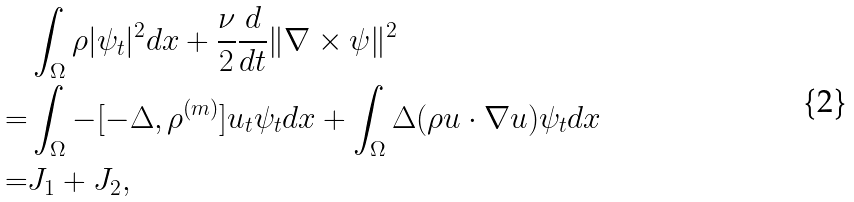Convert formula to latex. <formula><loc_0><loc_0><loc_500><loc_500>& \int _ { \Omega } \rho | \psi _ { t } | ^ { 2 } d x + \frac { \nu } { 2 } \frac { d } { d t } \| \nabla \times \psi \| ^ { 2 } \\ = & \int _ { \Omega } - [ - \Delta , \rho ^ { ( m ) } ] u _ { t } \psi _ { t } d x + \int _ { \Omega } \Delta ( \rho u \cdot \nabla u ) \psi _ { t } d x \\ = & J _ { 1 } + J _ { 2 } ,</formula> 